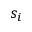<formula> <loc_0><loc_0><loc_500><loc_500>s _ { i }</formula> 